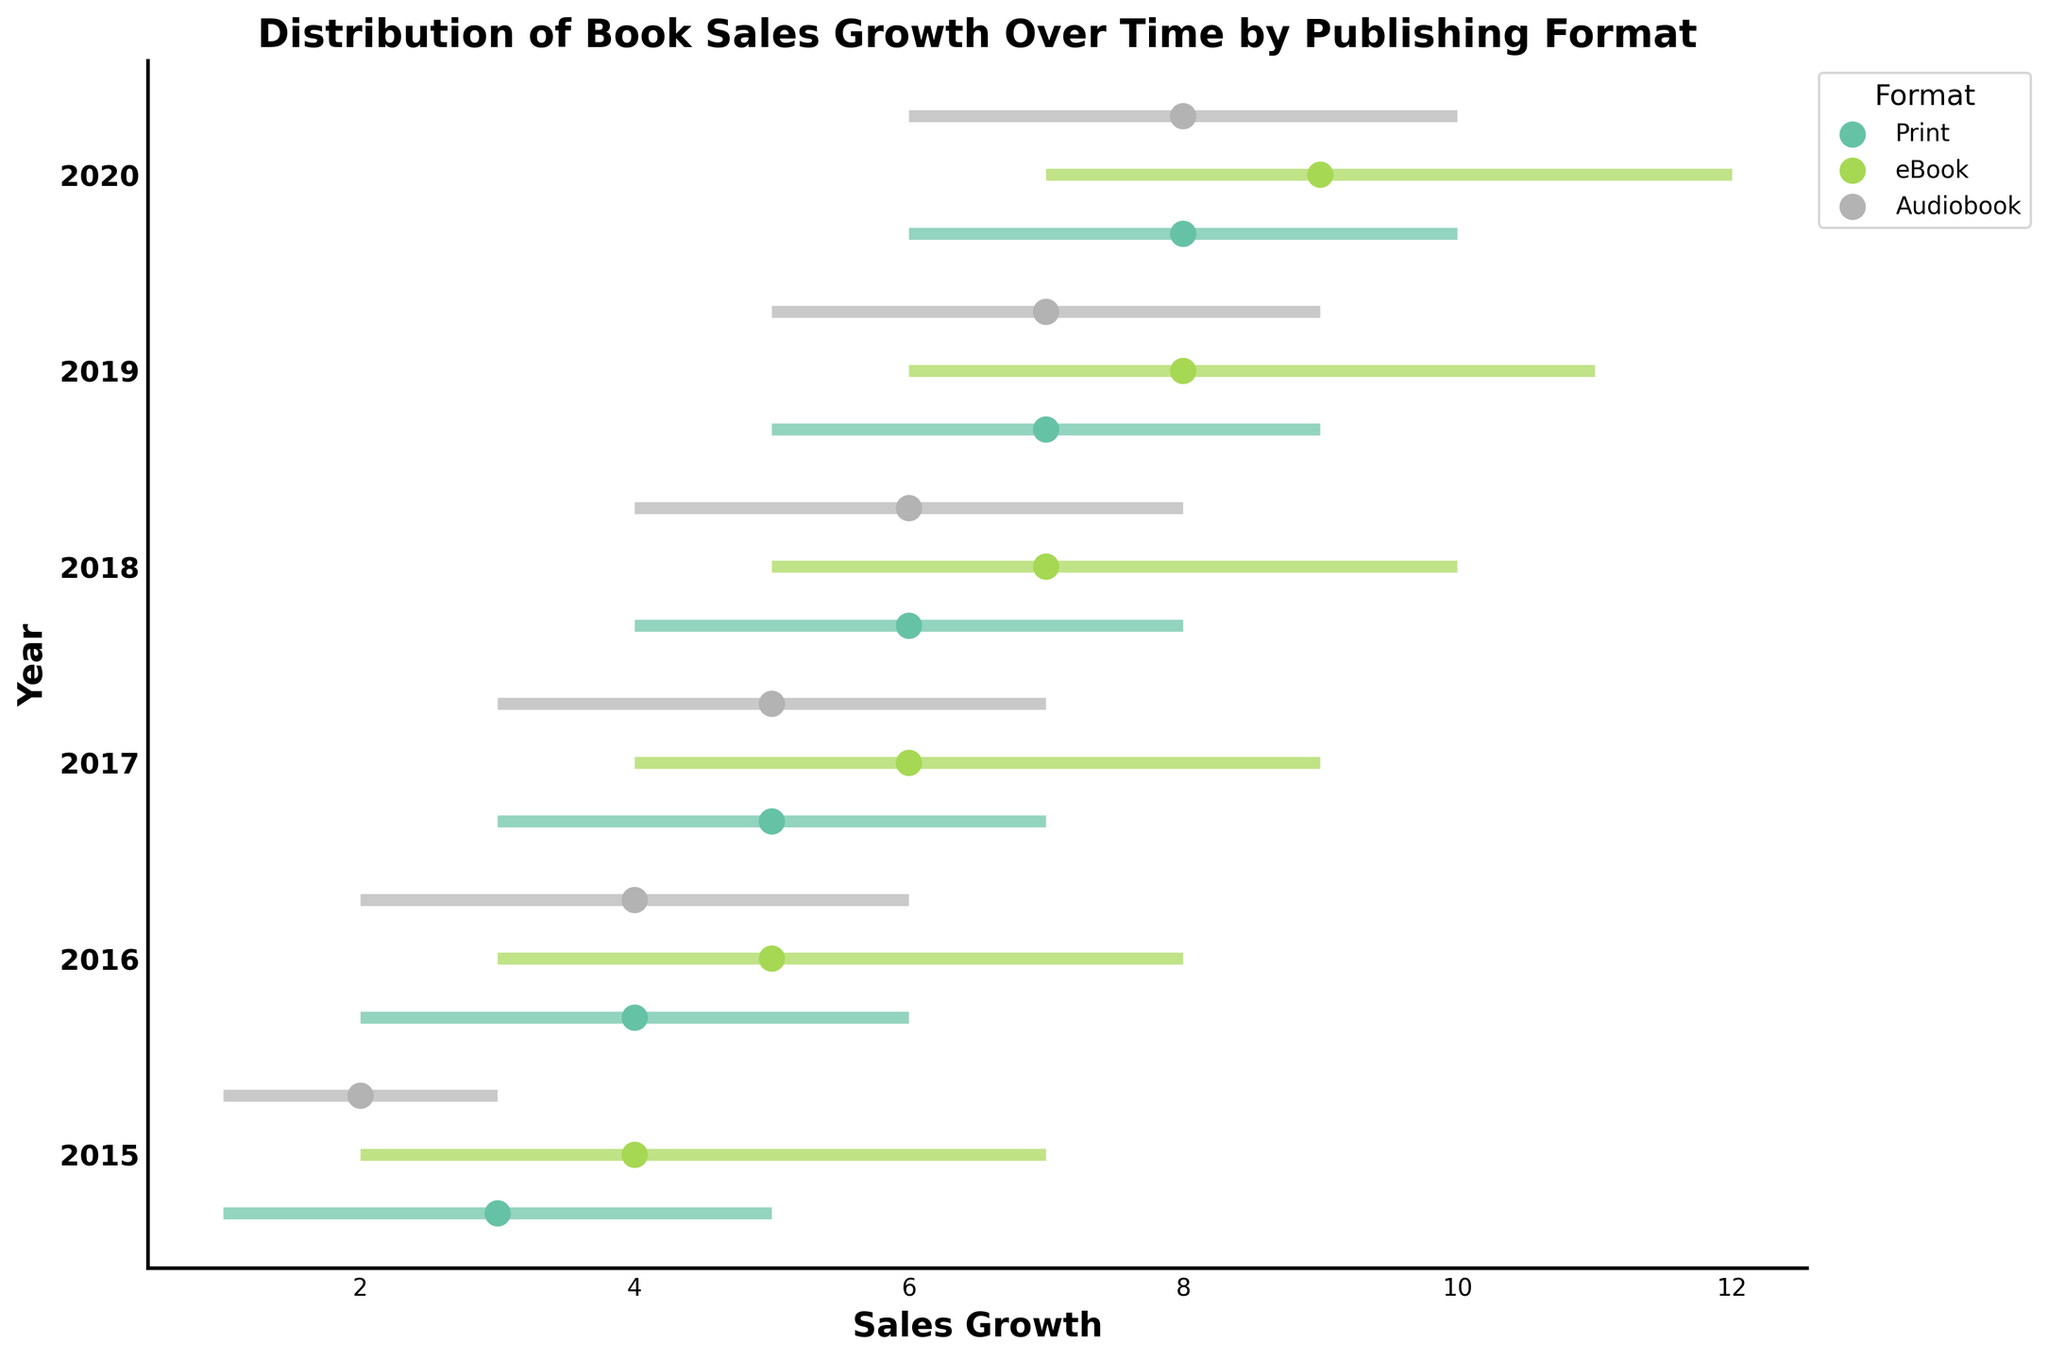What's the title of the plot? The title of the plot is shown at the top of the graph. It reads "Distribution of Book Sales Growth Over Time by Publishing Format."
Answer: Distribution of Book Sales Growth Over Time by Publishing Format Which format had the highest upper quartile value in 2020? The plot shows lines representing the lower quartile, median, and upper quartile for each format. The upper quartile value for eBooks in 2020 is 12, which is the highest among all the formats.
Answer: eBook In 2018, which format had a higher median value, Print or Audiobook? To find the median value for each format in 2018, locate the dots on the plot corresponding to the median. Print has a median value of 6, while Audiobook also has a median value of 6.
Answer: Both are equal How did the median growth of Print books change from 2015 to 2020? Check the median values of Print format from 2015 and 2020. In 2015, it's 3, and in 2020, it's 8. Subtract 3 from 8 to get the difference.
Answer: Increased by 5 What is the difference between the upper quartile value of eBooks and Audiobooks in 2019? Locate the upper quartile values for eBooks and Audiobooks in 2019. For eBooks, it's 11, and for Audiobooks, it's 9. Subtract 9 from 11 to find the difference.
Answer: 2 Which year shows the smallest range (difference between upper and lower quartiles) for Audiobooks? Identify the range for each year by subtracting the lower quartile from the upper quartile for Audiobooks. The smallest range is in 2015, with a range of 3 - 1 = 2.
Answer: 2015 In which year did Print books surpass a median value of 5? Look for the year where the median value for Print books first exceeds 5. In 2017, the median value is 5 and in 2018 it is 6, so 2018 is the year.
Answer: 2018 Compare the median values of eBooks in 2018 and 2020. Which year had a higher median? Look at the median values for eBooks in the years 2018 and 2020. In 2018, the median is 7, and in 2020, it's 9.
Answer: 2020 What is the overall trend in sales growth for Audiobooks between 2015 and 2020? Follow the median values for Audiobooks from 2015 to 2020. They steadily increase from 2 in 2015 to 8 in 2020, indicating an upward trend.
Answer: Increasing Which format showed the most consistent growth (smallest range variability) from 2015 to 2020? To determine consistency, compare the range (difference between upper and lower quartiles) for each format over the years. Audiobooks tend to have smaller ranges of 2-4, indicating more consistent growth than Print and eBooks.
Answer: Audiobook 